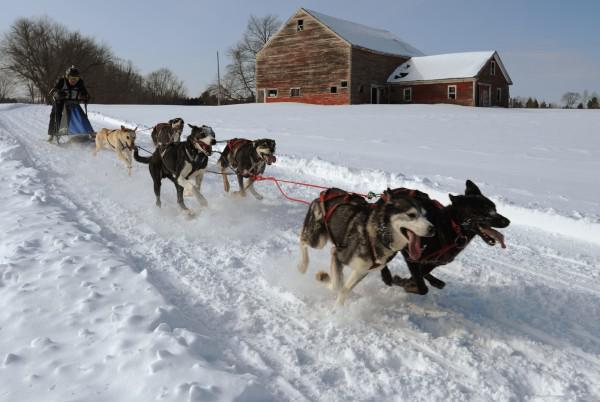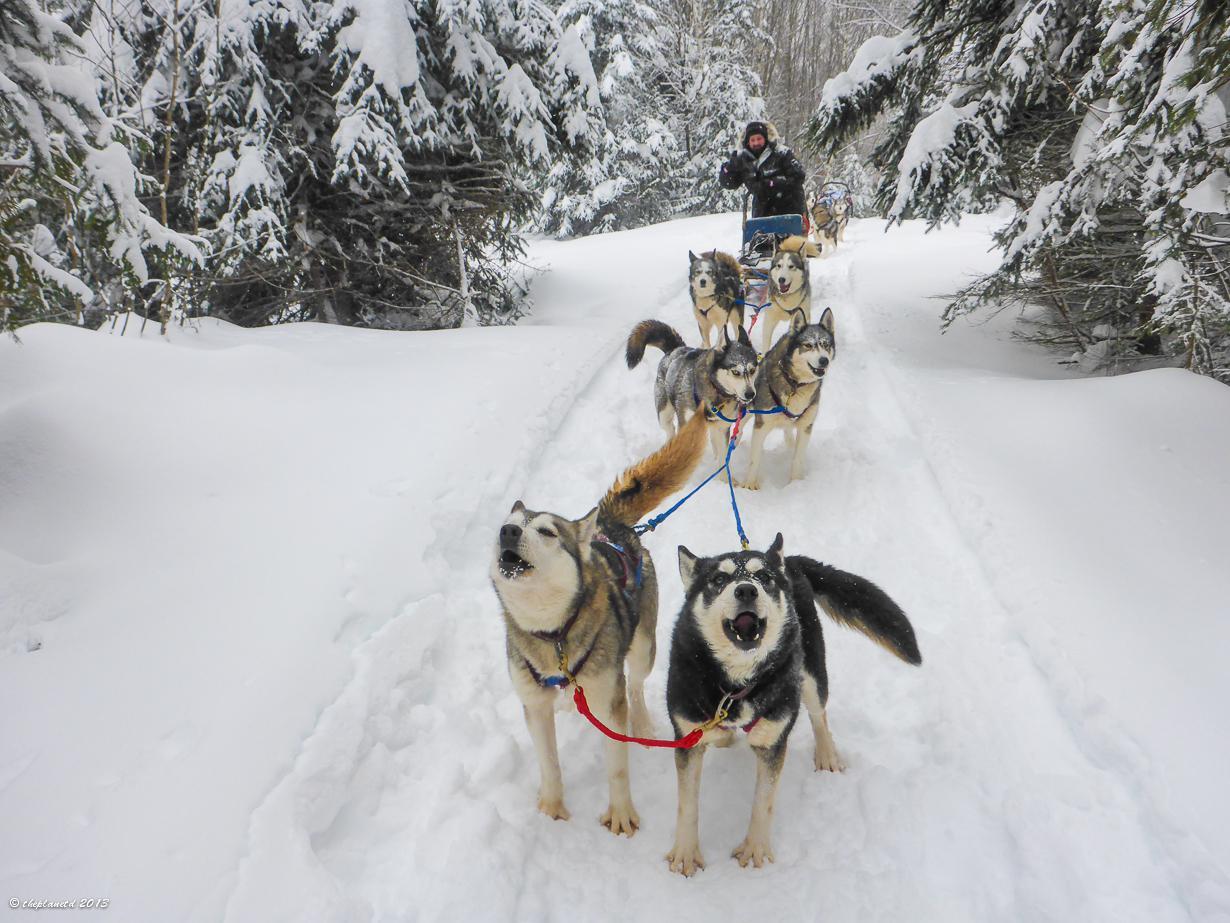The first image is the image on the left, the second image is the image on the right. Analyze the images presented: Is the assertion "An image shows a sled pulled by two dogs, heading downward and leftward." valid? Answer yes or no. No. The first image is the image on the left, the second image is the image on the right. Given the left and right images, does the statement "The image on the left has a person using a red sled." hold true? Answer yes or no. No. 